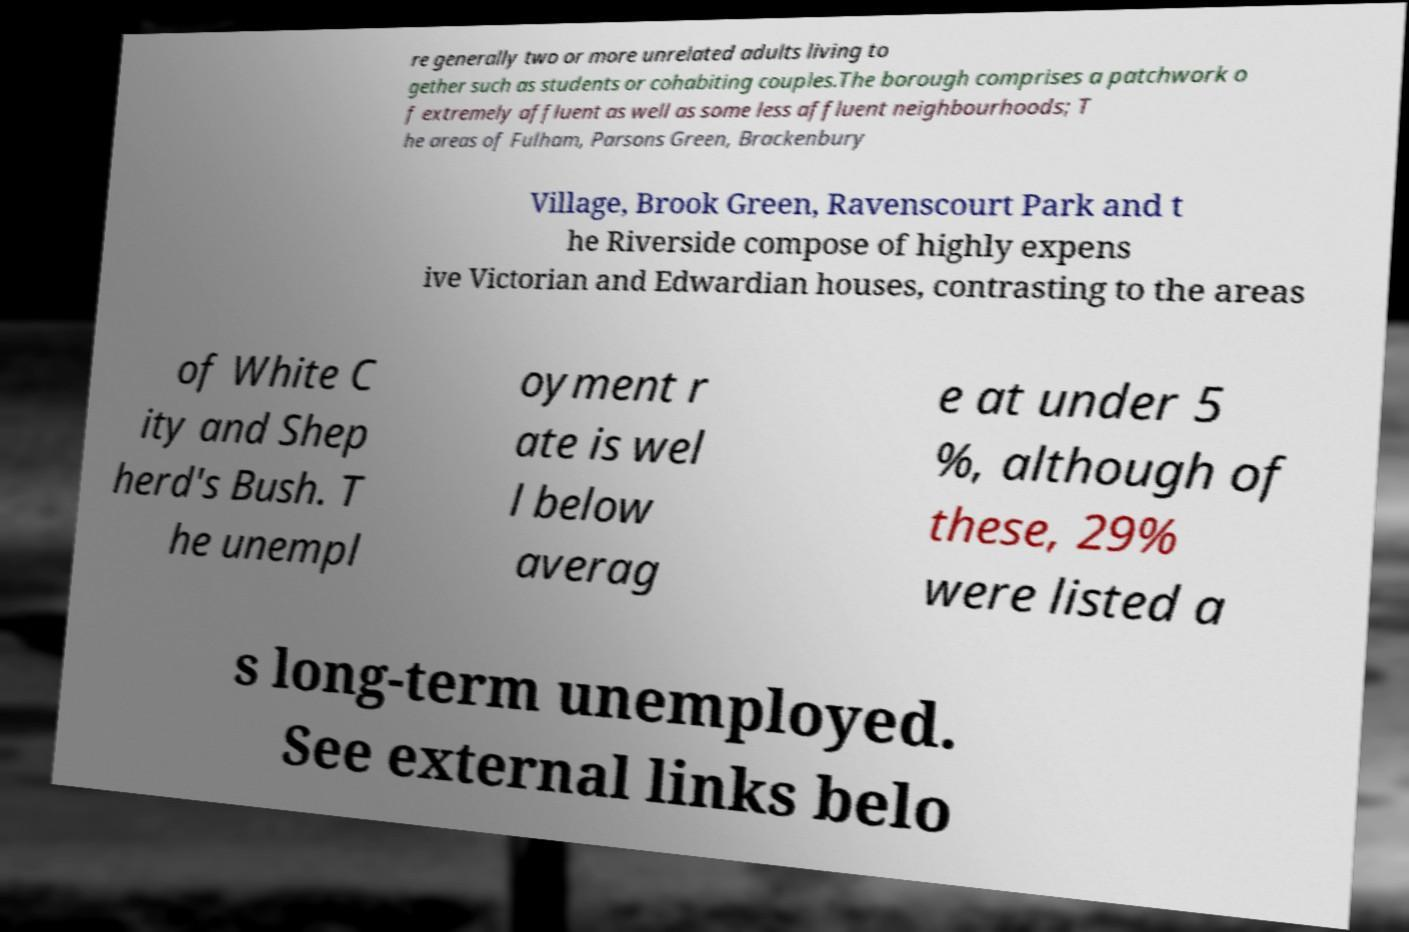I need the written content from this picture converted into text. Can you do that? re generally two or more unrelated adults living to gether such as students or cohabiting couples.The borough comprises a patchwork o f extremely affluent as well as some less affluent neighbourhoods; T he areas of Fulham, Parsons Green, Brackenbury Village, Brook Green, Ravenscourt Park and t he Riverside compose of highly expens ive Victorian and Edwardian houses, contrasting to the areas of White C ity and Shep herd's Bush. T he unempl oyment r ate is wel l below averag e at under 5 %, although of these, 29% were listed a s long-term unemployed. See external links belo 